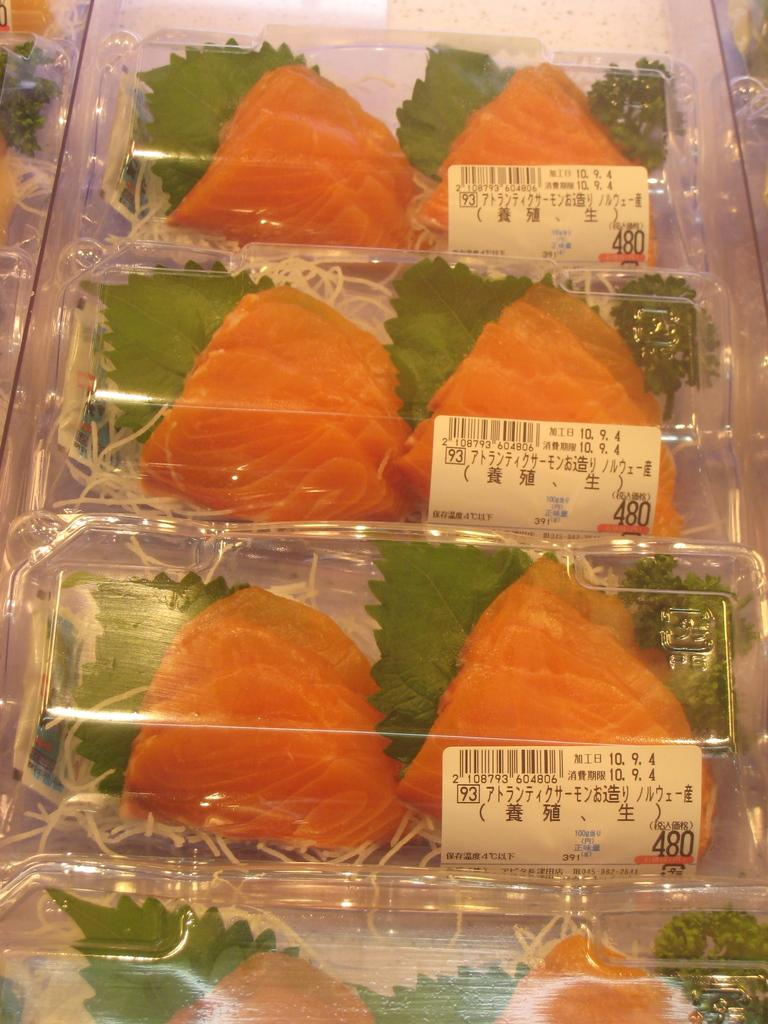What type of food can be seen in the image? There are slices of fish in the image. How are the slices of fish being stored or transported? The slices of fish are packed in a plastic bag. What type of fear can be seen in the image? There is no fear present in the image; it features slices of fish packed in a plastic bag. How many cherries are visible in the image? There are no cherries present in the image. 